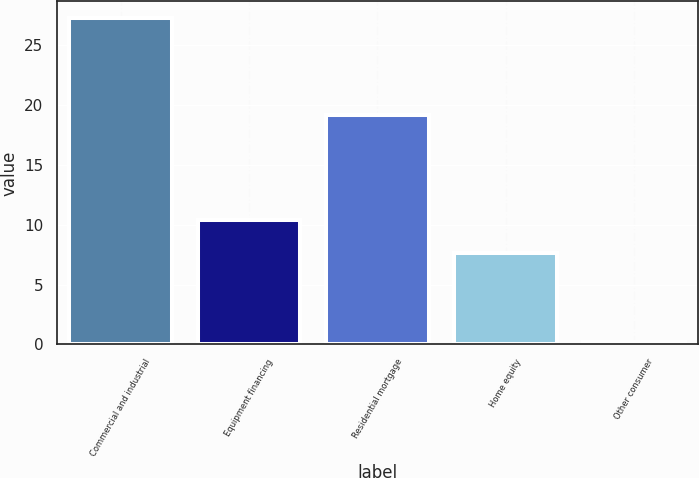Convert chart. <chart><loc_0><loc_0><loc_500><loc_500><bar_chart><fcel>Commercial and industrial<fcel>Equipment financing<fcel>Residential mortgage<fcel>Home equity<fcel>Other consumer<nl><fcel>27.3<fcel>10.4<fcel>19.2<fcel>7.6<fcel>0.2<nl></chart> 